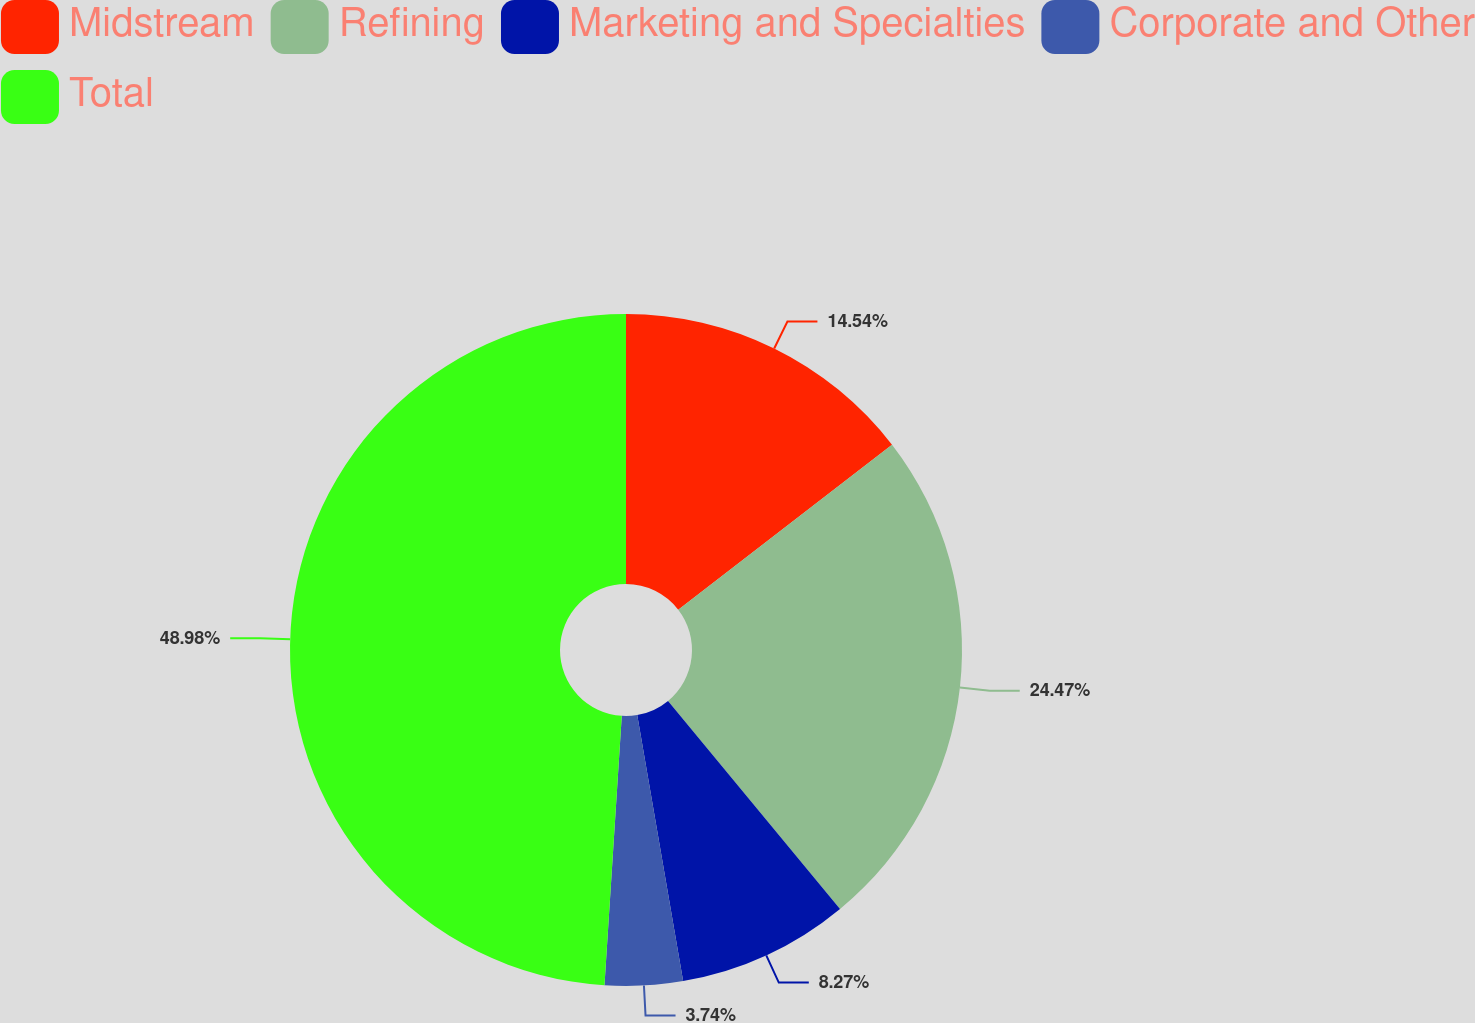Convert chart to OTSL. <chart><loc_0><loc_0><loc_500><loc_500><pie_chart><fcel>Midstream<fcel>Refining<fcel>Marketing and Specialties<fcel>Corporate and Other<fcel>Total<nl><fcel>14.54%<fcel>24.47%<fcel>8.27%<fcel>3.74%<fcel>48.98%<nl></chart> 